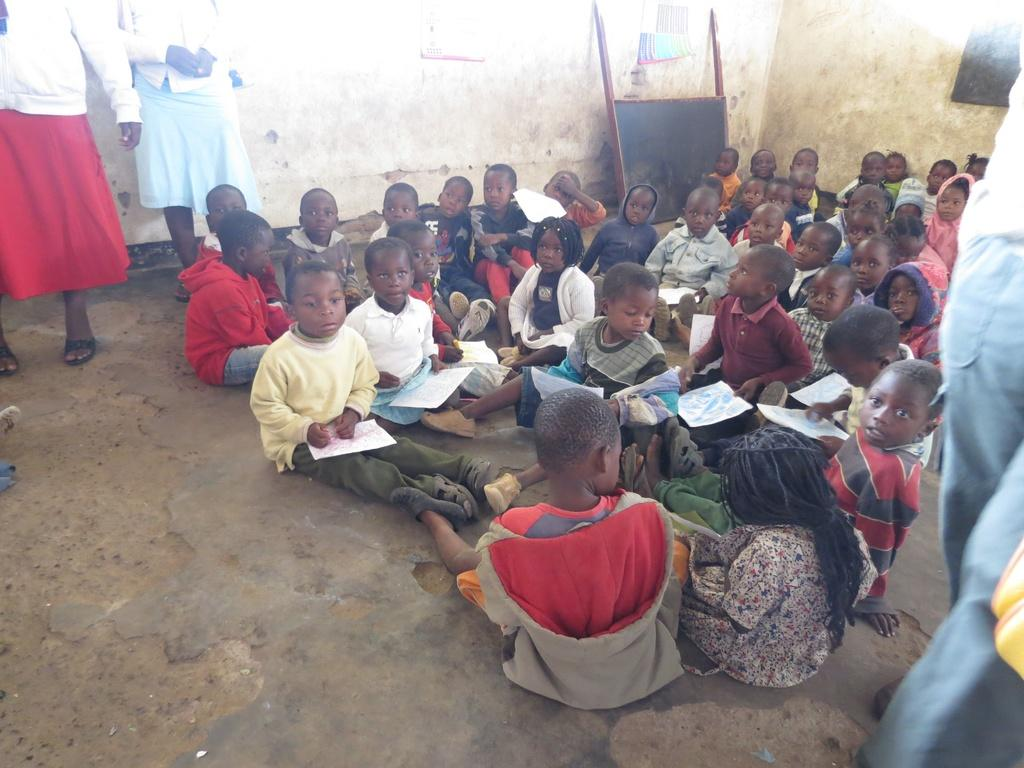What are the children in the image doing? The children in the image are sitting on the ground. What are the children holding in their hands? The children are holding papers. Can you describe the people standing in the image? There are persons standing in the image. What color is the board in the image? The board in the image is black in color. What is the color of the wall in the image? The wall in the image is cream in color. How many children are pointing at the board in the image? There is no indication in the image that any children are pointing at the board. 